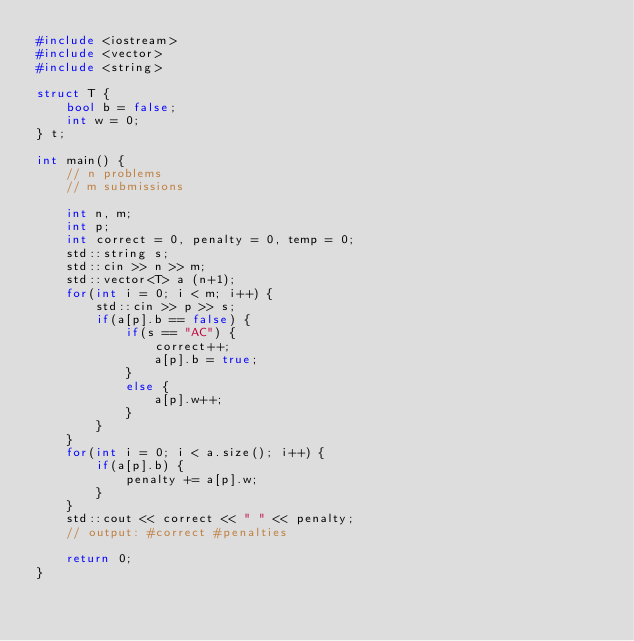Convert code to text. <code><loc_0><loc_0><loc_500><loc_500><_C++_>#include <iostream>
#include <vector>
#include <string>

struct T {
    bool b = false;
    int w = 0;
} t;

int main() {
    // n problems
    // m submissions

    int n, m;
    int p;
    int correct = 0, penalty = 0, temp = 0;
    std::string s;
    std::cin >> n >> m;
    std::vector<T> a (n+1);
    for(int i = 0; i < m; i++) {
        std::cin >> p >> s;
        if(a[p].b == false) {
            if(s == "AC") {
                correct++;
                a[p].b = true;
            }
            else {
                a[p].w++;
            }
        }
    }
    for(int i = 0; i < a.size(); i++) {
        if(a[p].b) {
            penalty += a[p].w;
        }
    }
    std::cout << correct << " " << penalty;
    // output: #correct #penalties

    return 0;
}</code> 